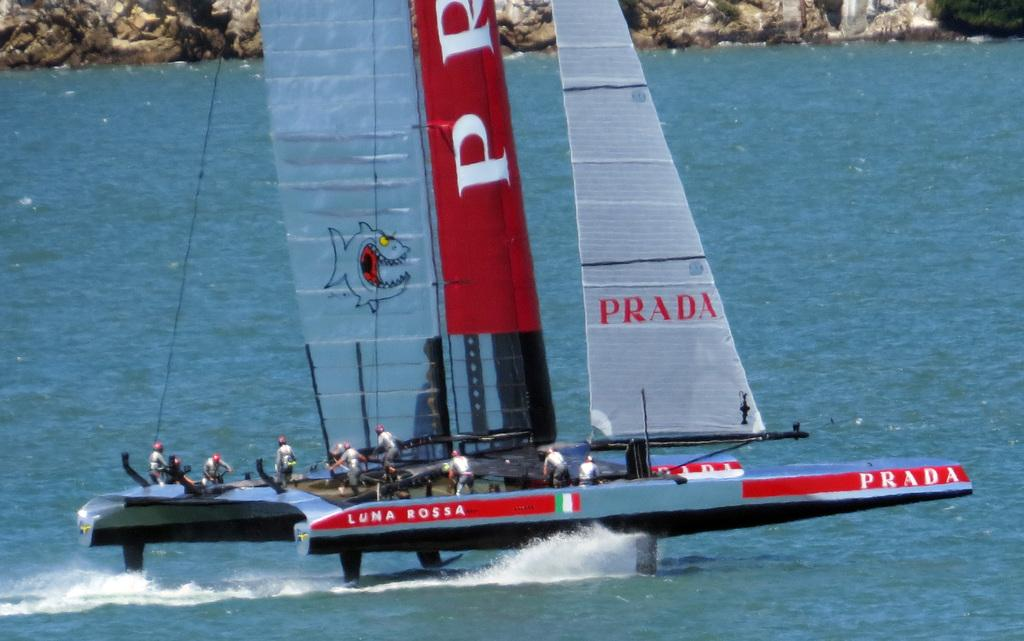What is the main subject of the image? The main subject of the image is a boat. Are there any people in the image? Yes, there are people in the image. What can be seen in the background of the image? There is water visible in the image. What type of surface is at the top of the image? There is a rock surface at the top of the image. What type of honey is being collected by the people in the image? There is no honey or honey collection activity present in the image. How many groups of people can be seen in the image? There is no mention of groups in the image; there are simply people present. 